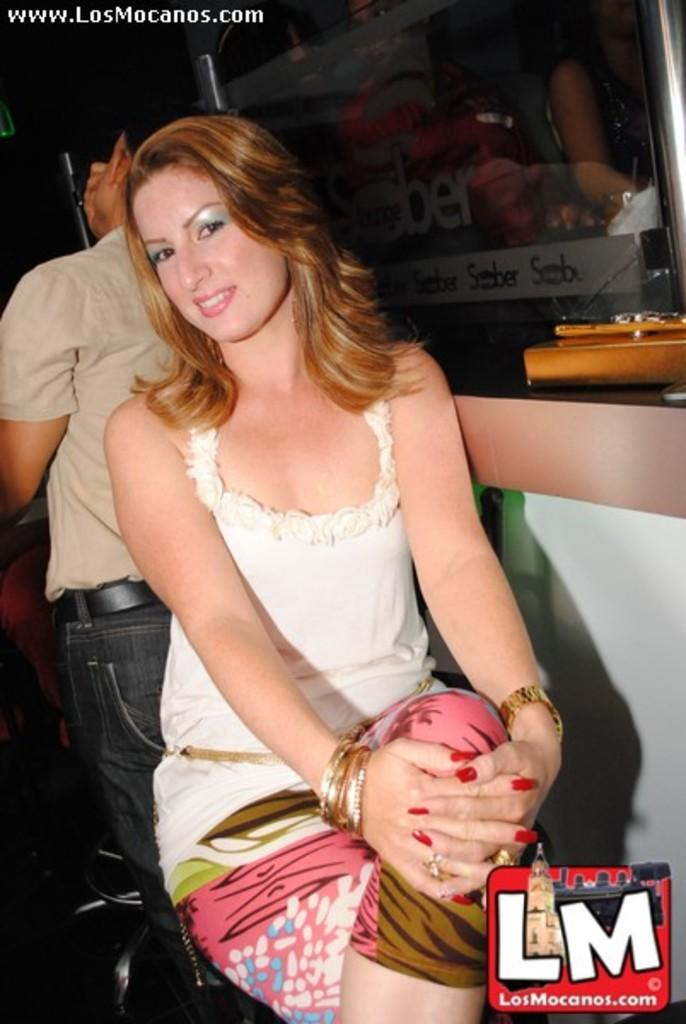What is the woman in the image doing? The woman is sitting on a chair in the image. Where is the woman located in the image? The woman is in the middle of the image. Can you describe the man in the image? There is a man behind the woman in the image. Is there any text or marking in the image? Yes, there is a watermark in the bottom right side of the image. What type of gun is the woman holding in the image? There is no gun present in the image; the woman is sitting on a chair and there is a man behind her. 